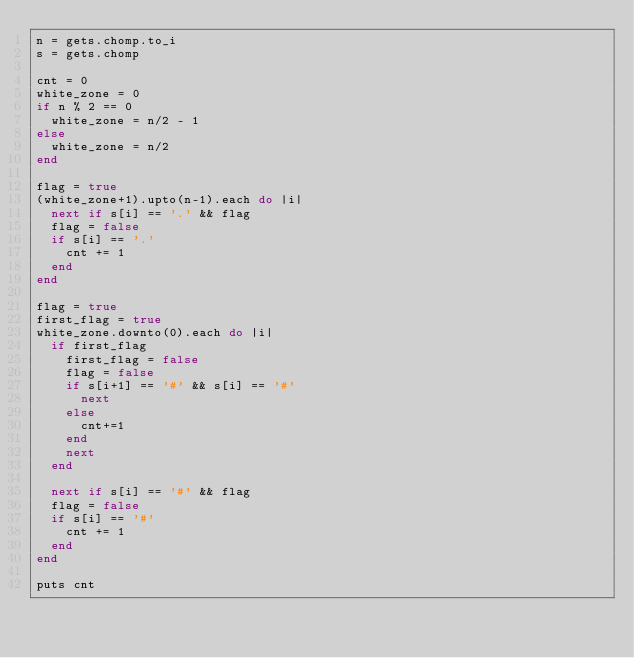<code> <loc_0><loc_0><loc_500><loc_500><_Ruby_>n = gets.chomp.to_i
s = gets.chomp

cnt = 0
white_zone = 0
if n % 2 == 0
  white_zone = n/2 - 1
else
  white_zone = n/2
end

flag = true
(white_zone+1).upto(n-1).each do |i|
  next if s[i] == '.' && flag
  flag = false
  if s[i] == '.'
    cnt += 1
  end
end

flag = true
first_flag = true
white_zone.downto(0).each do |i|
  if first_flag
    first_flag = false
    flag = false
    if s[i+1] == '#' && s[i] == '#'
      next
    else
      cnt+=1
    end
    next
  end

  next if s[i] == '#' && flag
  flag = false
  if s[i] == '#'
    cnt += 1
  end
end

puts cnt
</code> 